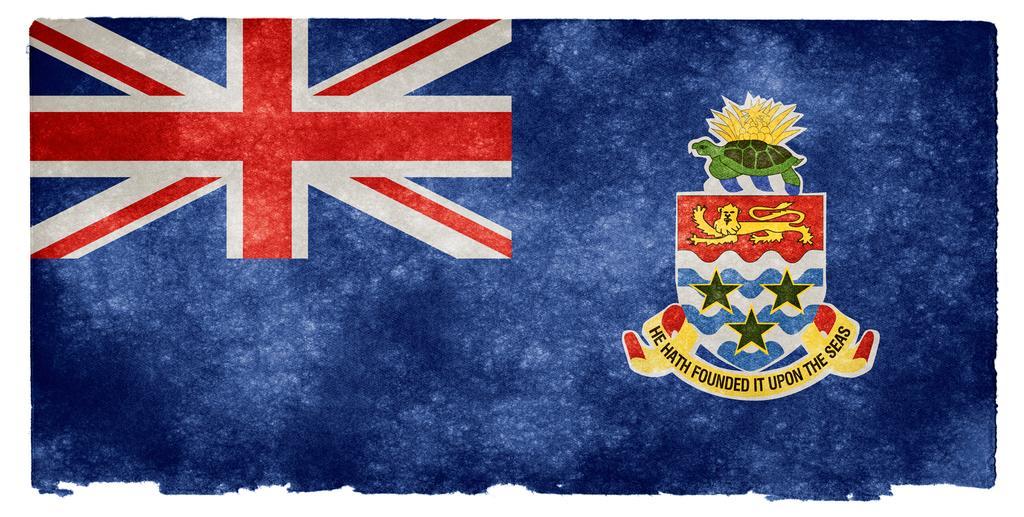In one or two sentences, can you explain what this image depicts? This image looks like an edited photo, in which I can see a flag. 